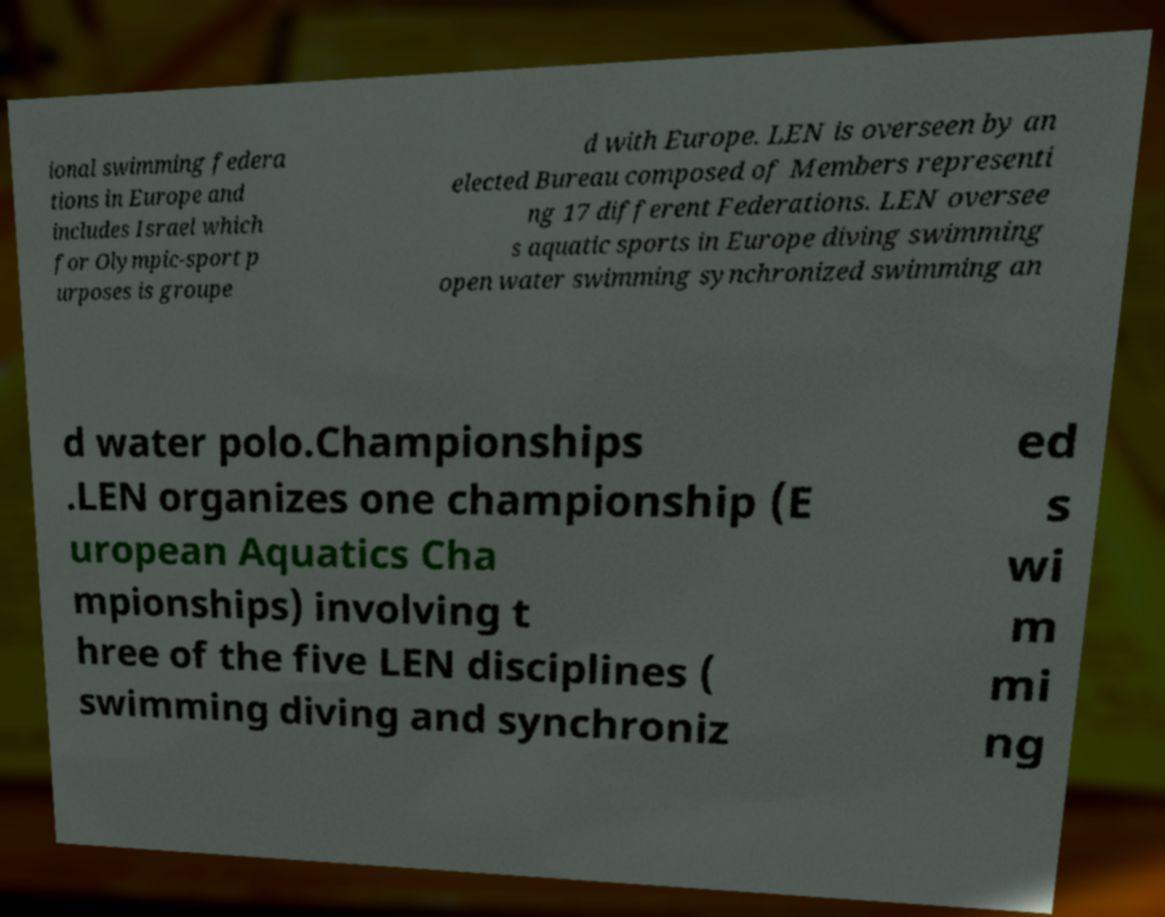For documentation purposes, I need the text within this image transcribed. Could you provide that? ional swimming federa tions in Europe and includes Israel which for Olympic-sport p urposes is groupe d with Europe. LEN is overseen by an elected Bureau composed of Members representi ng 17 different Federations. LEN oversee s aquatic sports in Europe diving swimming open water swimming synchronized swimming an d water polo.Championships .LEN organizes one championship (E uropean Aquatics Cha mpionships) involving t hree of the five LEN disciplines ( swimming diving and synchroniz ed s wi m mi ng 